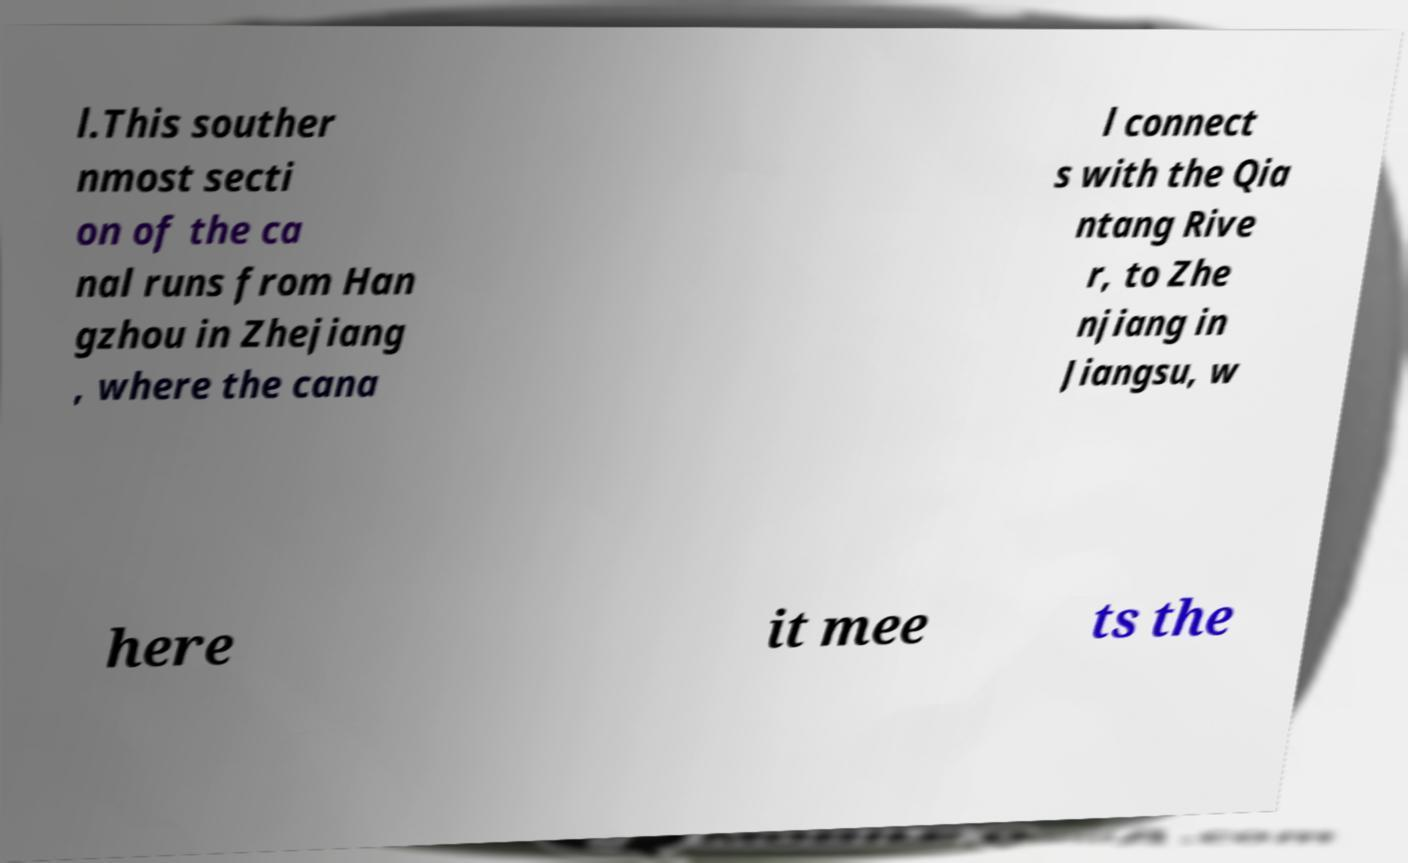I need the written content from this picture converted into text. Can you do that? l.This souther nmost secti on of the ca nal runs from Han gzhou in Zhejiang , where the cana l connect s with the Qia ntang Rive r, to Zhe njiang in Jiangsu, w here it mee ts the 